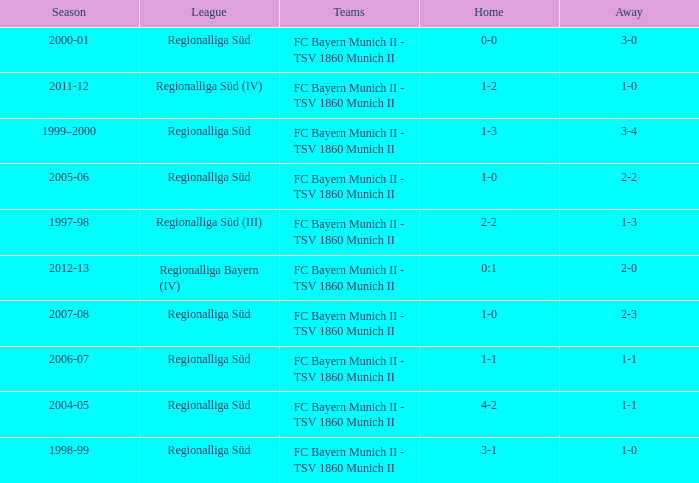What season has a regionalliga süd league, a 1-0 home, and an away of 2-3? 2007-08. 